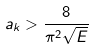Convert formula to latex. <formula><loc_0><loc_0><loc_500><loc_500>a _ { k } > \frac { 8 } { \pi ^ { 2 } \sqrt { E } }</formula> 